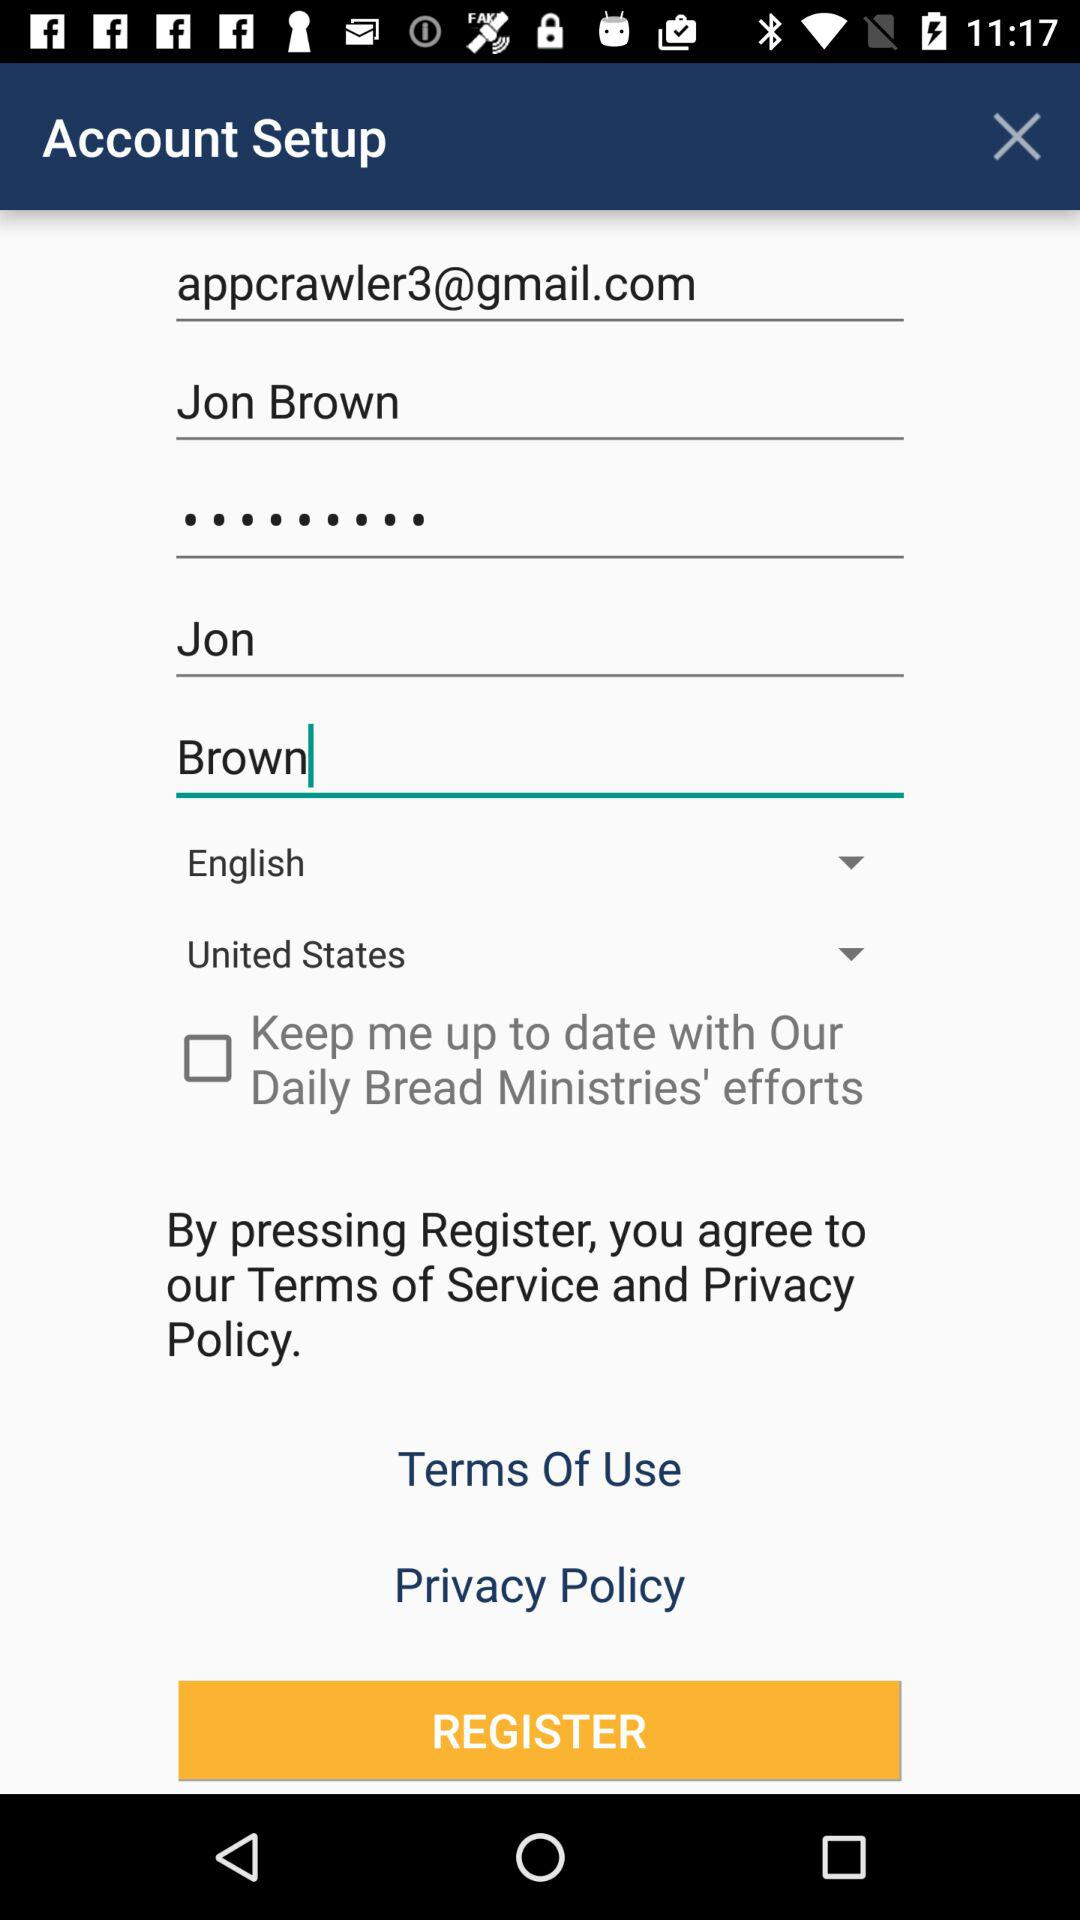What is the name of the user? The name of the user is Jon Brown. 